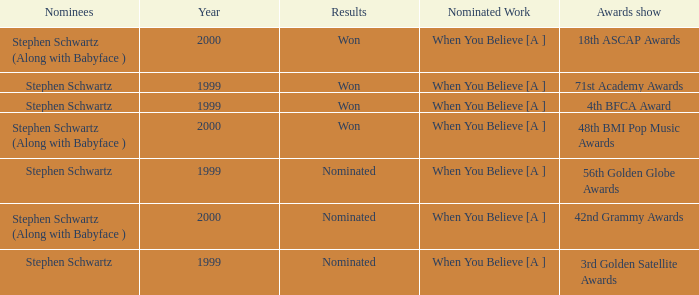What was the result in 2000? Won, Won, Nominated. 